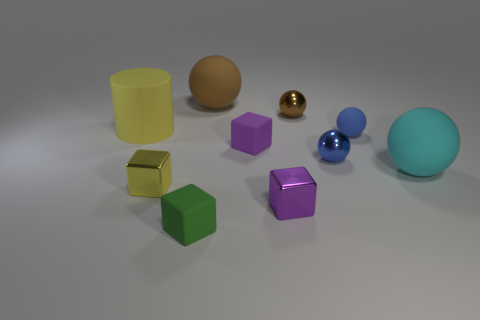Subtract all brown spheres. How many purple blocks are left? 2 Subtract all purple matte cubes. How many cubes are left? 3 Subtract all yellow cubes. How many cubes are left? 3 Subtract 2 blocks. How many blocks are left? 2 Subtract all cylinders. How many objects are left? 9 Subtract all cyan metallic things. Subtract all yellow rubber cylinders. How many objects are left? 9 Add 8 tiny purple blocks. How many tiny purple blocks are left? 10 Add 4 purple metal balls. How many purple metal balls exist? 4 Subtract 0 green spheres. How many objects are left? 10 Subtract all purple cubes. Subtract all red cylinders. How many cubes are left? 2 